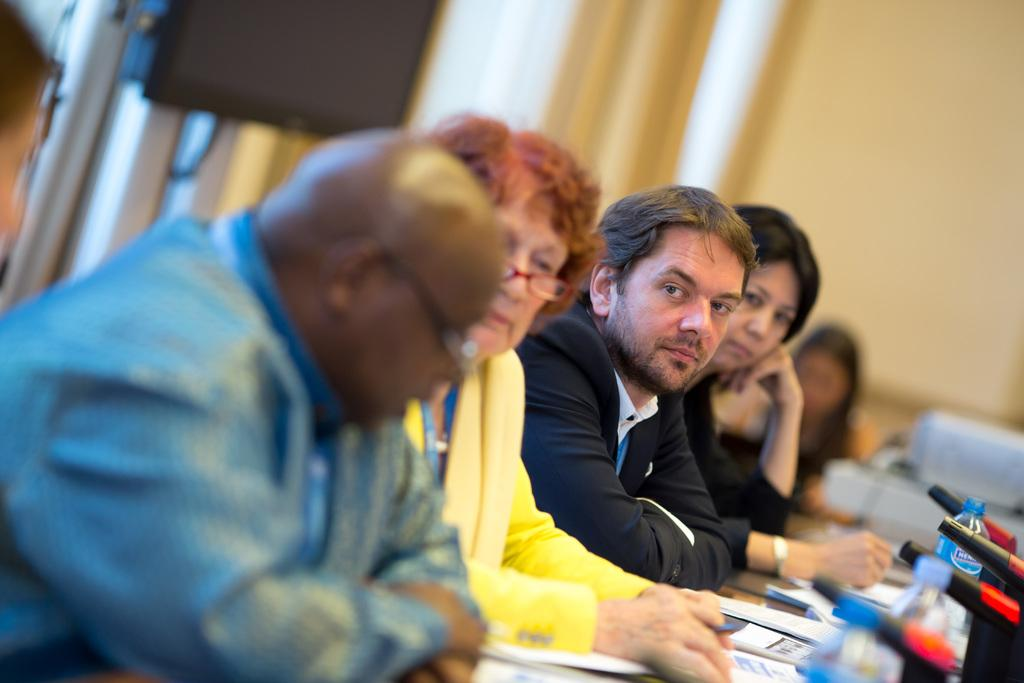What are the people in the image doing? The people in the image are sitting. What objects can be seen on the desk in the image? There are notepads and bottles on the desk in the image. How many toes can be seen in the image? There are no toes visible in the image. What type of roll is being used by the people in the image? There is no roll present in the image. 